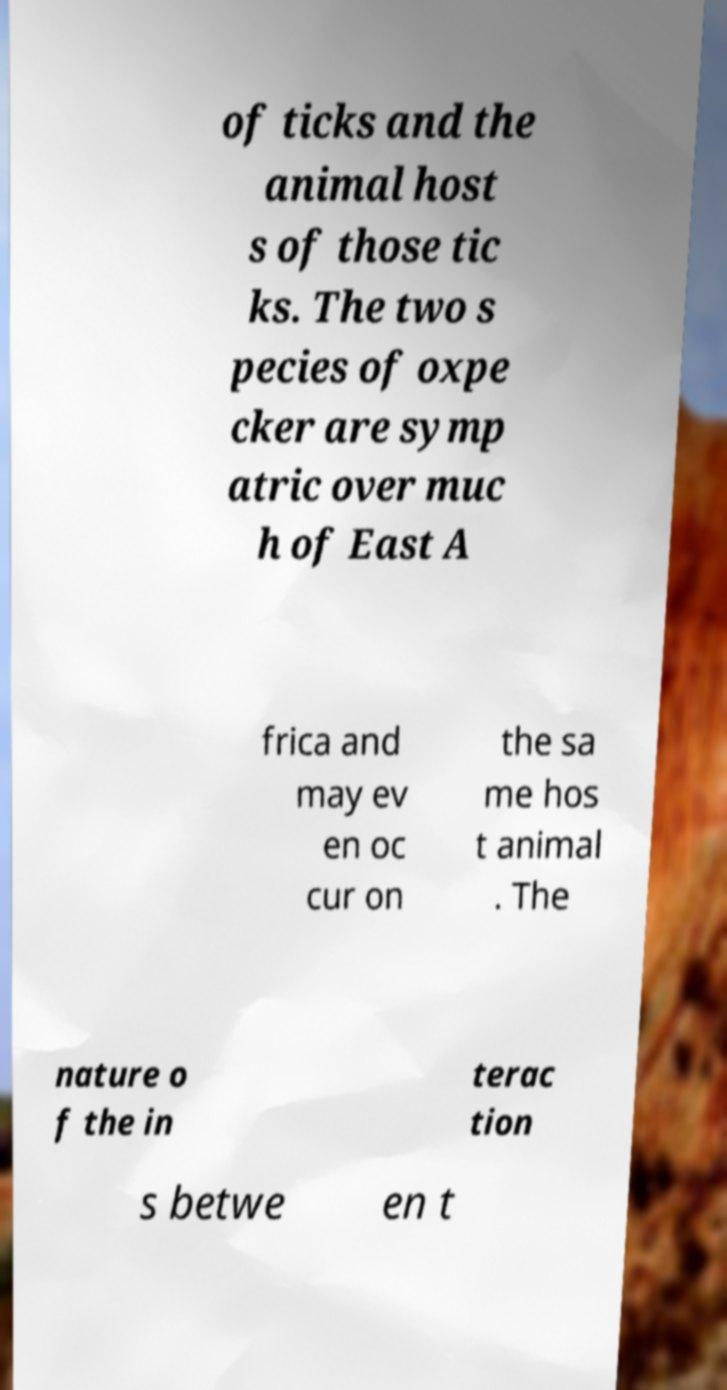What messages or text are displayed in this image? I need them in a readable, typed format. of ticks and the animal host s of those tic ks. The two s pecies of oxpe cker are symp atric over muc h of East A frica and may ev en oc cur on the sa me hos t animal . The nature o f the in terac tion s betwe en t 